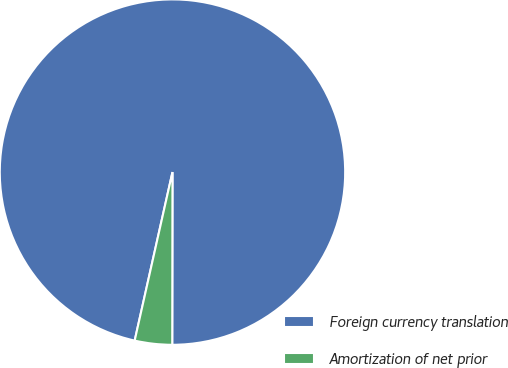<chart> <loc_0><loc_0><loc_500><loc_500><pie_chart><fcel>Foreign currency translation<fcel>Amortization of net prior<nl><fcel>96.51%<fcel>3.49%<nl></chart> 